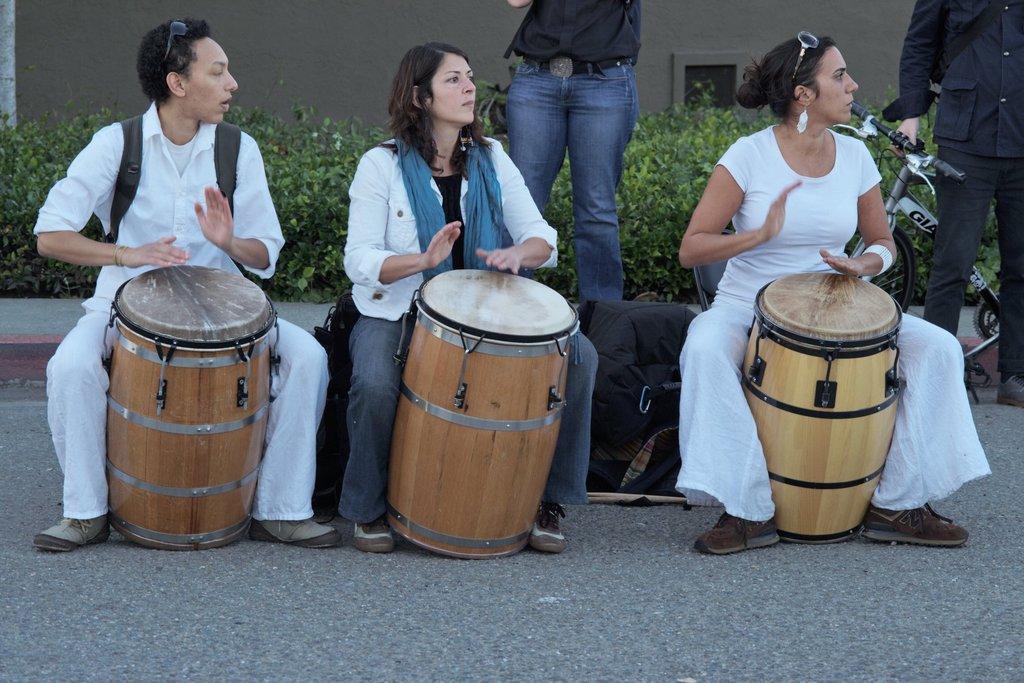Can you describe this image briefly? In this image three people wearing white shirt are playing drums. Behind them a person is standing. In the right a person is holding a bicycle. Behind them there are plants. There is a wall in the background. 